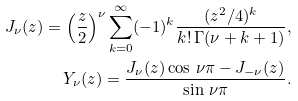<formula> <loc_0><loc_0><loc_500><loc_500>J _ { \nu } ( z ) = \left ( \frac { z } { 2 } \right ) ^ { \nu } \sum _ { k = 0 } ^ { \infty } ( - 1 ) ^ { k } \frac { ( z ^ { 2 } / 4 ) ^ { k } } { k ! \, \Gamma ( \nu + k + 1 ) } , \\ Y _ { \nu } ( z ) = \frac { J _ { \nu } ( z ) \cos \, \nu { \pi } - J _ { - \nu } ( z ) } { \sin \, { \nu } \pi } .</formula> 